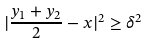<formula> <loc_0><loc_0><loc_500><loc_500>| \frac { y _ { 1 } + y _ { 2 } } { 2 } - x | ^ { 2 } \geq \delta ^ { 2 }</formula> 